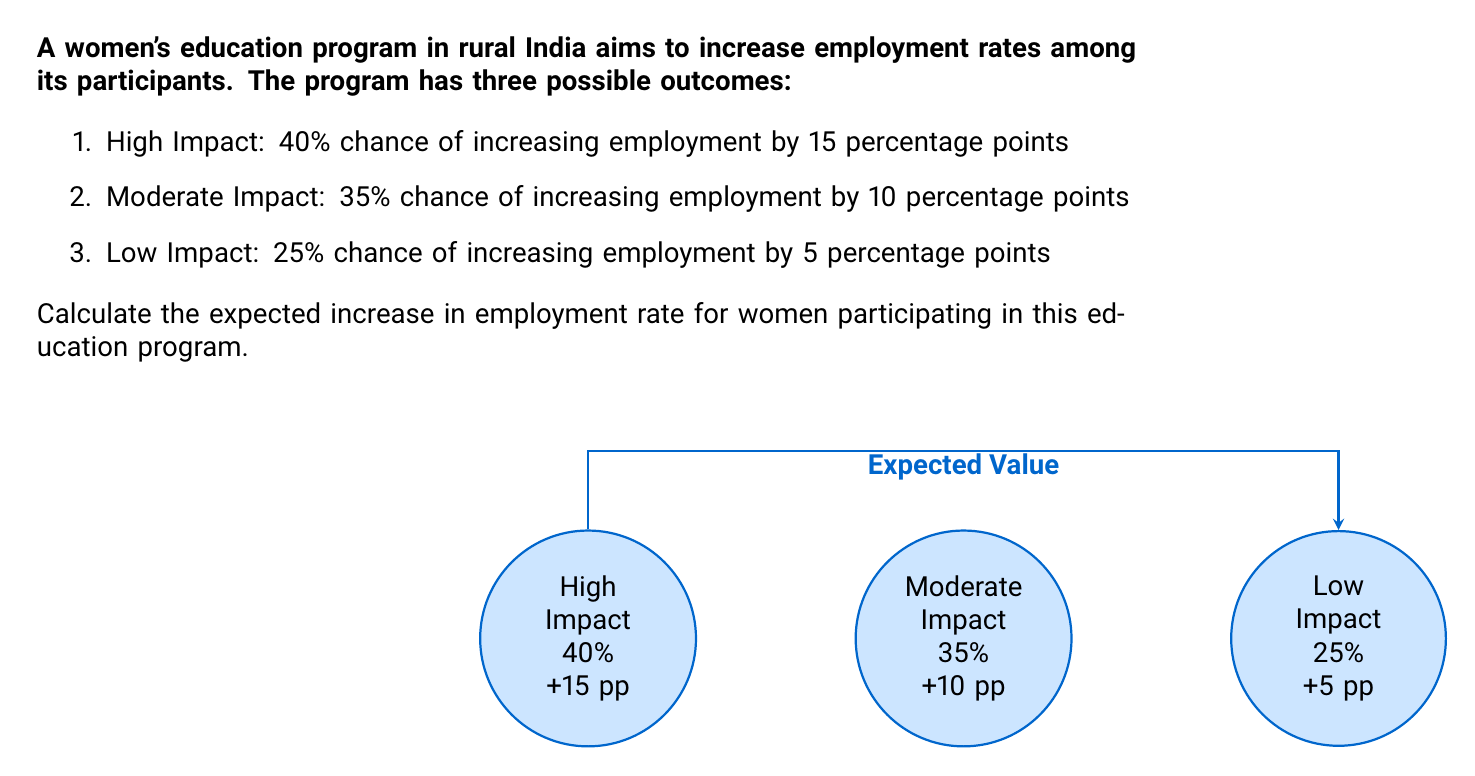Solve this math problem. To calculate the expected increase in employment rate, we need to use the concept of expected value. The expected value is the sum of each possible outcome multiplied by its probability.

Let's break it down step-by-step:

1) First, let's define our variables:
   $p_1 = 0.40$, $v_1 = 15$ (High Impact)
   $p_2 = 0.35$, $v_2 = 10$ (Moderate Impact)
   $p_3 = 0.25$, $v_3 = 5$ (Low Impact)

2) The formula for expected value is:
   $$E = p_1v_1 + p_2v_2 + p_3v_3$$

3) Now, let's substitute our values:
   $$E = (0.40 \times 15) + (0.35 \times 10) + (0.25 \times 5)$$

4) Let's calculate each term:
   $$E = 6 + 3.5 + 1.25$$

5) Sum up the terms:
   $$E = 10.75$$

Therefore, the expected increase in employment rate is 10.75 percentage points.
Answer: 10.75 percentage points 